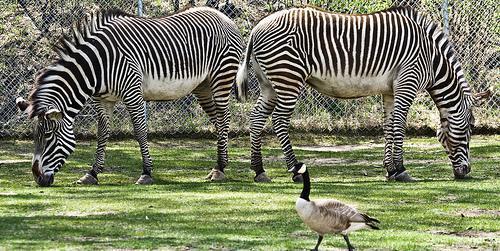How many birds are shown?
Give a very brief answer. 1. 